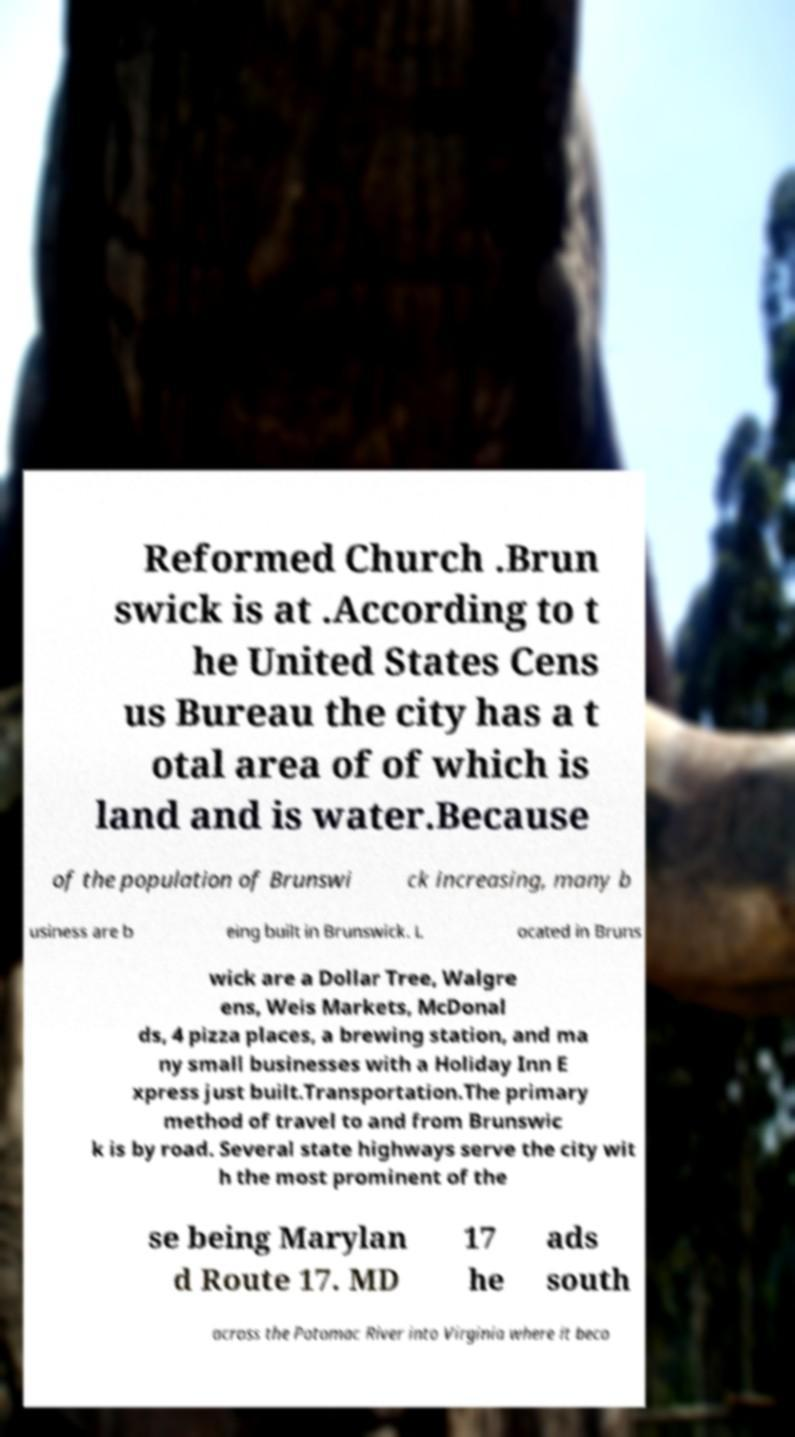For documentation purposes, I need the text within this image transcribed. Could you provide that? Reformed Church .Brun swick is at .According to t he United States Cens us Bureau the city has a t otal area of of which is land and is water.Because of the population of Brunswi ck increasing, many b usiness are b eing built in Brunswick. L ocated in Bruns wick are a Dollar Tree, Walgre ens, Weis Markets, McDonal ds, 4 pizza places, a brewing station, and ma ny small businesses with a Holiday Inn E xpress just built.Transportation.The primary method of travel to and from Brunswic k is by road. Several state highways serve the city wit h the most prominent of the se being Marylan d Route 17. MD 17 he ads south across the Potomac River into Virginia where it beco 